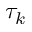<formula> <loc_0><loc_0><loc_500><loc_500>\tau _ { k }</formula> 